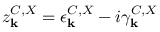Convert formula to latex. <formula><loc_0><loc_0><loc_500><loc_500>z _ { k } ^ { C , X } = \epsilon _ { k } ^ { C , X } - i \gamma _ { k } ^ { C , X }</formula> 